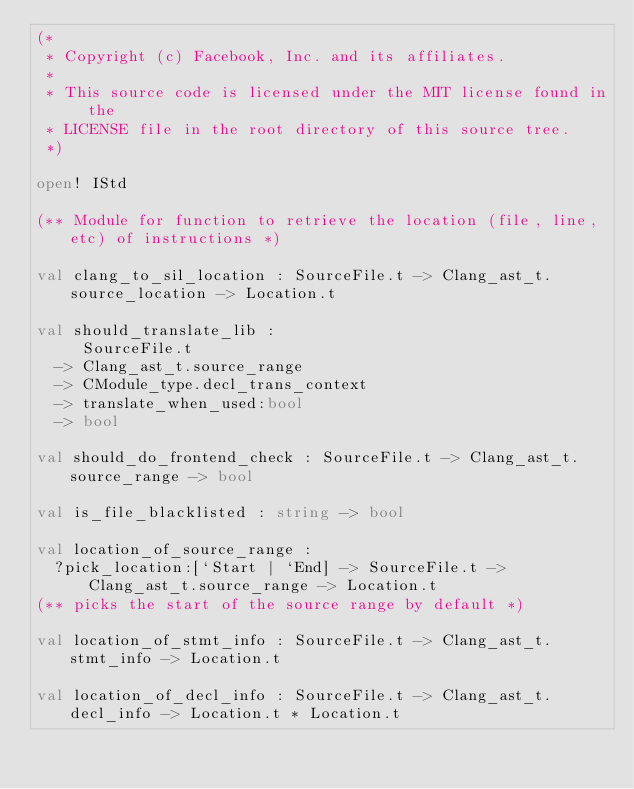<code> <loc_0><loc_0><loc_500><loc_500><_OCaml_>(*
 * Copyright (c) Facebook, Inc. and its affiliates.
 *
 * This source code is licensed under the MIT license found in the
 * LICENSE file in the root directory of this source tree.
 *)

open! IStd

(** Module for function to retrieve the location (file, line, etc) of instructions *)

val clang_to_sil_location : SourceFile.t -> Clang_ast_t.source_location -> Location.t

val should_translate_lib :
     SourceFile.t
  -> Clang_ast_t.source_range
  -> CModule_type.decl_trans_context
  -> translate_when_used:bool
  -> bool

val should_do_frontend_check : SourceFile.t -> Clang_ast_t.source_range -> bool

val is_file_blacklisted : string -> bool

val location_of_source_range :
  ?pick_location:[`Start | `End] -> SourceFile.t -> Clang_ast_t.source_range -> Location.t
(** picks the start of the source range by default *)

val location_of_stmt_info : SourceFile.t -> Clang_ast_t.stmt_info -> Location.t

val location_of_decl_info : SourceFile.t -> Clang_ast_t.decl_info -> Location.t * Location.t
</code> 